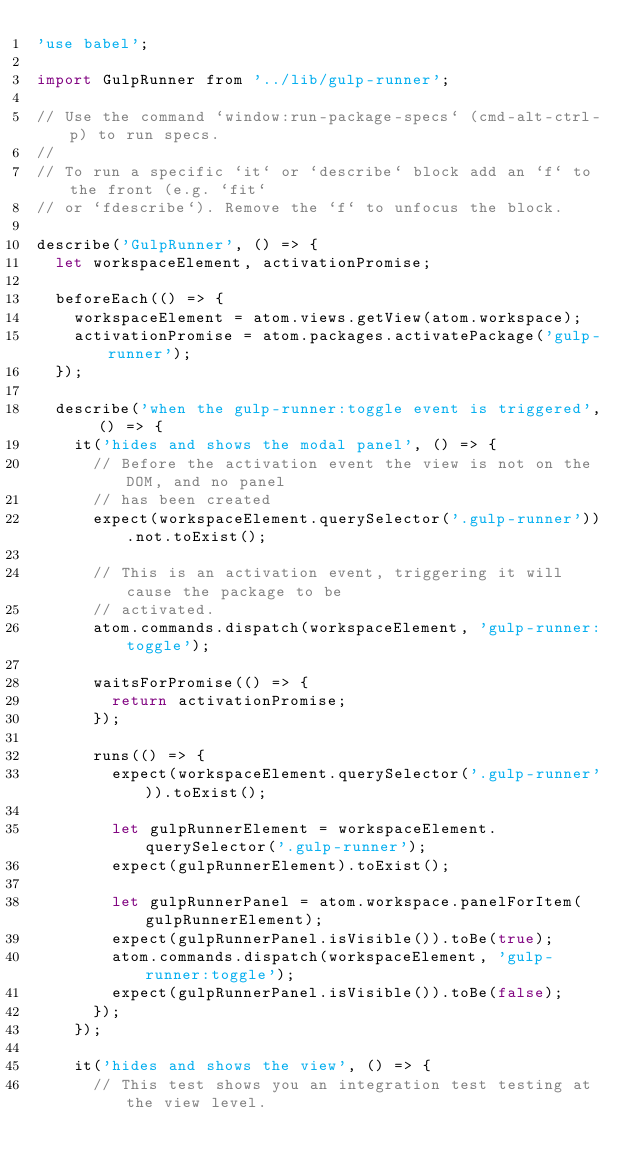Convert code to text. <code><loc_0><loc_0><loc_500><loc_500><_JavaScript_>'use babel';

import GulpRunner from '../lib/gulp-runner';

// Use the command `window:run-package-specs` (cmd-alt-ctrl-p) to run specs.
//
// To run a specific `it` or `describe` block add an `f` to the front (e.g. `fit`
// or `fdescribe`). Remove the `f` to unfocus the block.

describe('GulpRunner', () => {
  let workspaceElement, activationPromise;

  beforeEach(() => {
    workspaceElement = atom.views.getView(atom.workspace);
    activationPromise = atom.packages.activatePackage('gulp-runner');
  });

  describe('when the gulp-runner:toggle event is triggered', () => {
    it('hides and shows the modal panel', () => {
      // Before the activation event the view is not on the DOM, and no panel
      // has been created
      expect(workspaceElement.querySelector('.gulp-runner')).not.toExist();

      // This is an activation event, triggering it will cause the package to be
      // activated.
      atom.commands.dispatch(workspaceElement, 'gulp-runner:toggle');

      waitsForPromise(() => {
        return activationPromise;
      });

      runs(() => {
        expect(workspaceElement.querySelector('.gulp-runner')).toExist();

        let gulpRunnerElement = workspaceElement.querySelector('.gulp-runner');
        expect(gulpRunnerElement).toExist();

        let gulpRunnerPanel = atom.workspace.panelForItem(gulpRunnerElement);
        expect(gulpRunnerPanel.isVisible()).toBe(true);
        atom.commands.dispatch(workspaceElement, 'gulp-runner:toggle');
        expect(gulpRunnerPanel.isVisible()).toBe(false);
      });
    });

    it('hides and shows the view', () => {
      // This test shows you an integration test testing at the view level.
</code> 